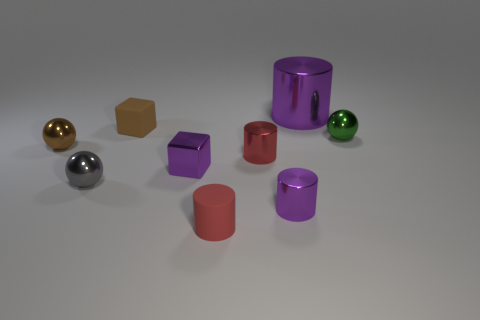Subtract all big cylinders. How many cylinders are left? 3 Add 1 large purple matte cylinders. How many objects exist? 10 Subtract all cubes. How many objects are left? 7 Subtract 2 cylinders. How many cylinders are left? 2 Subtract all purple cubes. How many cubes are left? 1 Subtract all green spheres. How many red cylinders are left? 2 Add 6 purple metal blocks. How many purple metal blocks exist? 7 Subtract 1 gray spheres. How many objects are left? 8 Subtract all gray cylinders. Subtract all yellow cubes. How many cylinders are left? 4 Subtract all metallic blocks. Subtract all large metallic things. How many objects are left? 7 